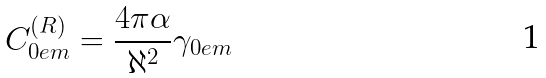Convert formula to latex. <formula><loc_0><loc_0><loc_500><loc_500>C _ { 0 e m } ^ { ( R ) } = \frac { 4 \pi \alpha } { \aleph ^ { 2 } } \gamma _ { 0 e m }</formula> 